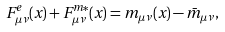Convert formula to latex. <formula><loc_0><loc_0><loc_500><loc_500>F ^ { e } _ { \mu \nu } ( x ) + F ^ { m * } _ { \mu \nu } ( x ) = m _ { \mu \nu } ( x ) - \bar { m } _ { \mu \nu } ,</formula> 